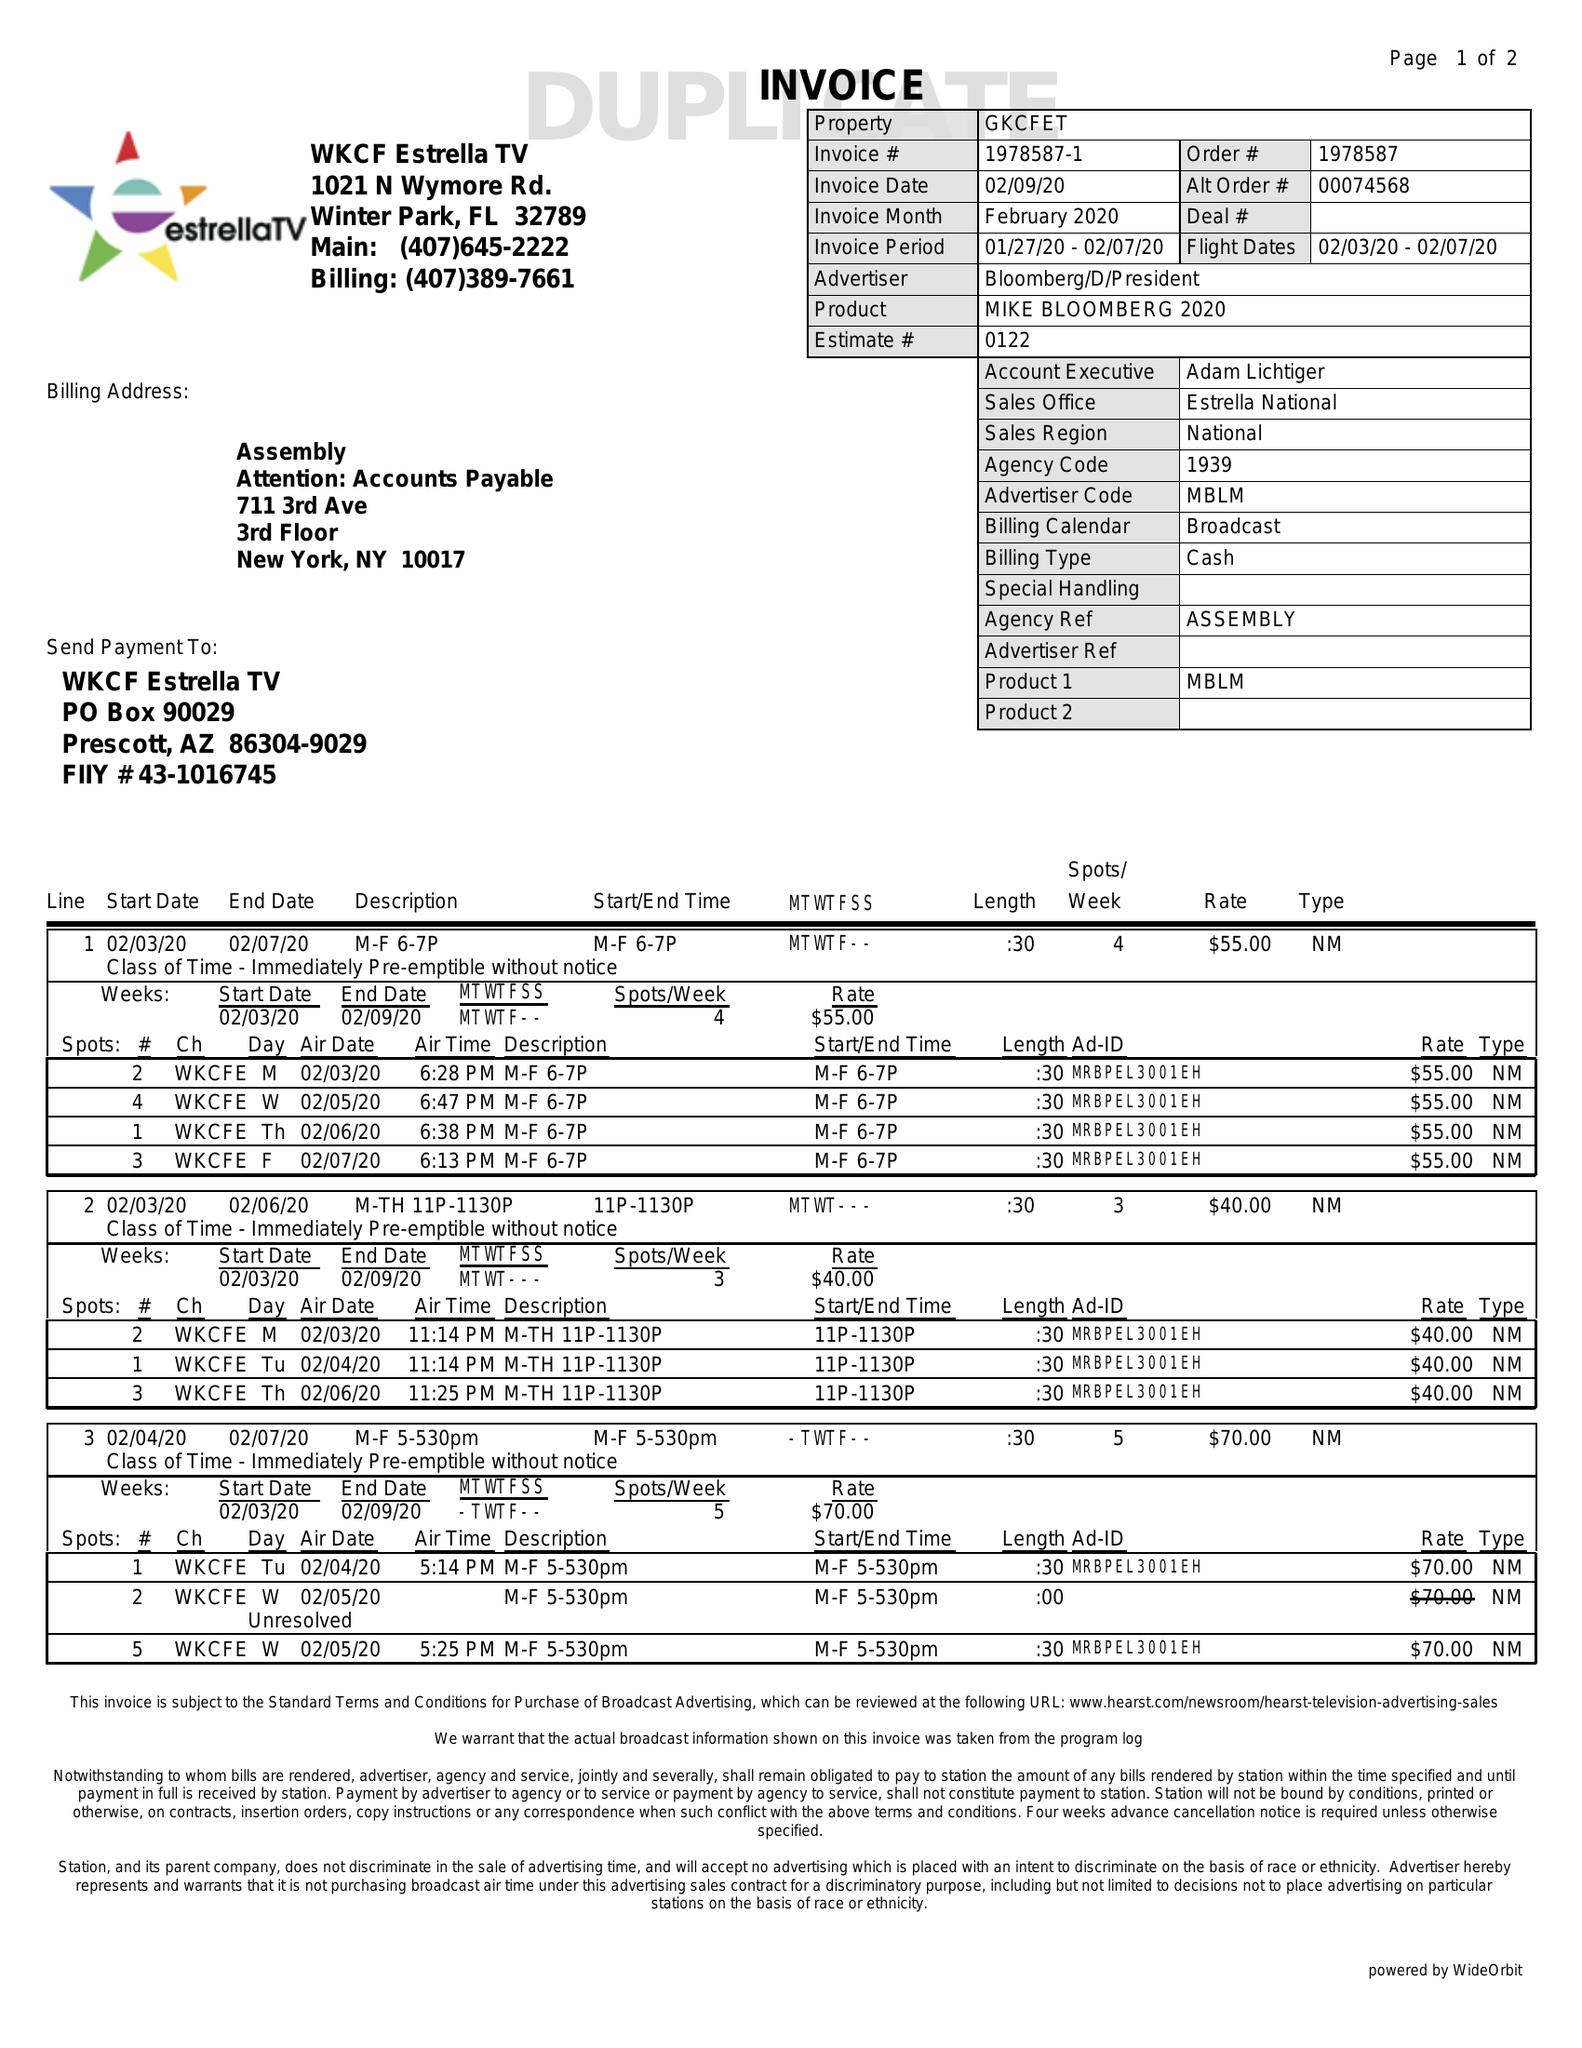What is the value for the gross_amount?
Answer the question using a single word or phrase. 865.00 